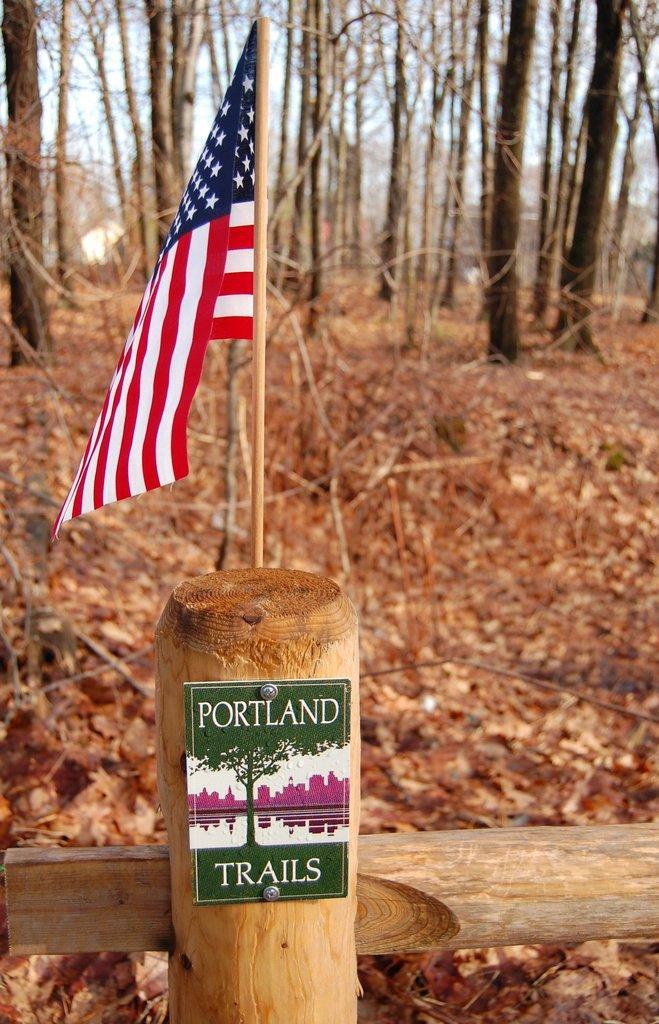Could you give a brief overview of what you see in this image? In front of the image there is a flag and a name board on the wooden fence, behind the fence there are trees there are dry leaves on the surface. 